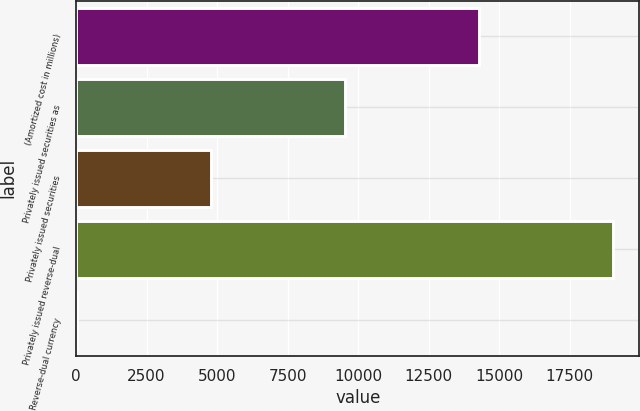<chart> <loc_0><loc_0><loc_500><loc_500><bar_chart><fcel>(Amortized cost in millions)<fcel>Privately issued securities as<fcel>Privately issued securities<fcel>Privately issued reverse-dual<fcel>Reverse-dual currency<nl><fcel>14275.3<fcel>9526.64<fcel>4777.97<fcel>19024<fcel>29.3<nl></chart> 